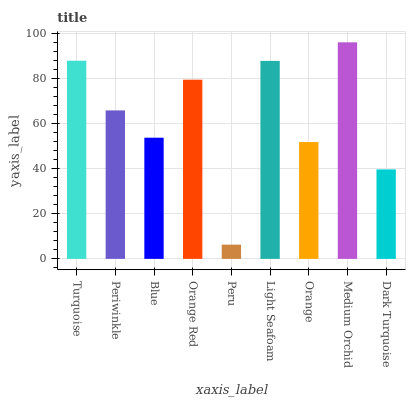Is Periwinkle the minimum?
Answer yes or no. No. Is Periwinkle the maximum?
Answer yes or no. No. Is Turquoise greater than Periwinkle?
Answer yes or no. Yes. Is Periwinkle less than Turquoise?
Answer yes or no. Yes. Is Periwinkle greater than Turquoise?
Answer yes or no. No. Is Turquoise less than Periwinkle?
Answer yes or no. No. Is Periwinkle the high median?
Answer yes or no. Yes. Is Periwinkle the low median?
Answer yes or no. Yes. Is Peru the high median?
Answer yes or no. No. Is Orange the low median?
Answer yes or no. No. 